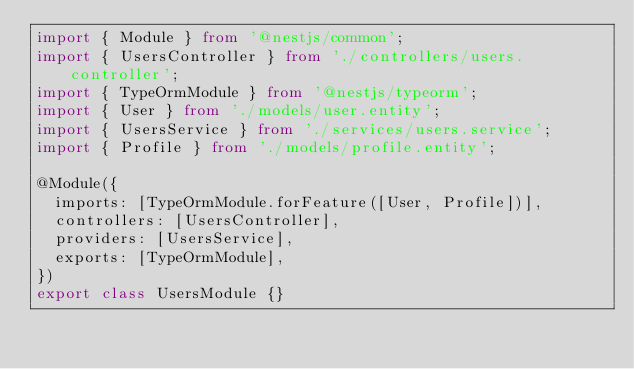Convert code to text. <code><loc_0><loc_0><loc_500><loc_500><_TypeScript_>import { Module } from '@nestjs/common';
import { UsersController } from './controllers/users.controller';
import { TypeOrmModule } from '@nestjs/typeorm';
import { User } from './models/user.entity';
import { UsersService } from './services/users.service';
import { Profile } from './models/profile.entity';

@Module({
  imports: [TypeOrmModule.forFeature([User, Profile])],
  controllers: [UsersController],
  providers: [UsersService],
  exports: [TypeOrmModule],
})
export class UsersModule {}
</code> 